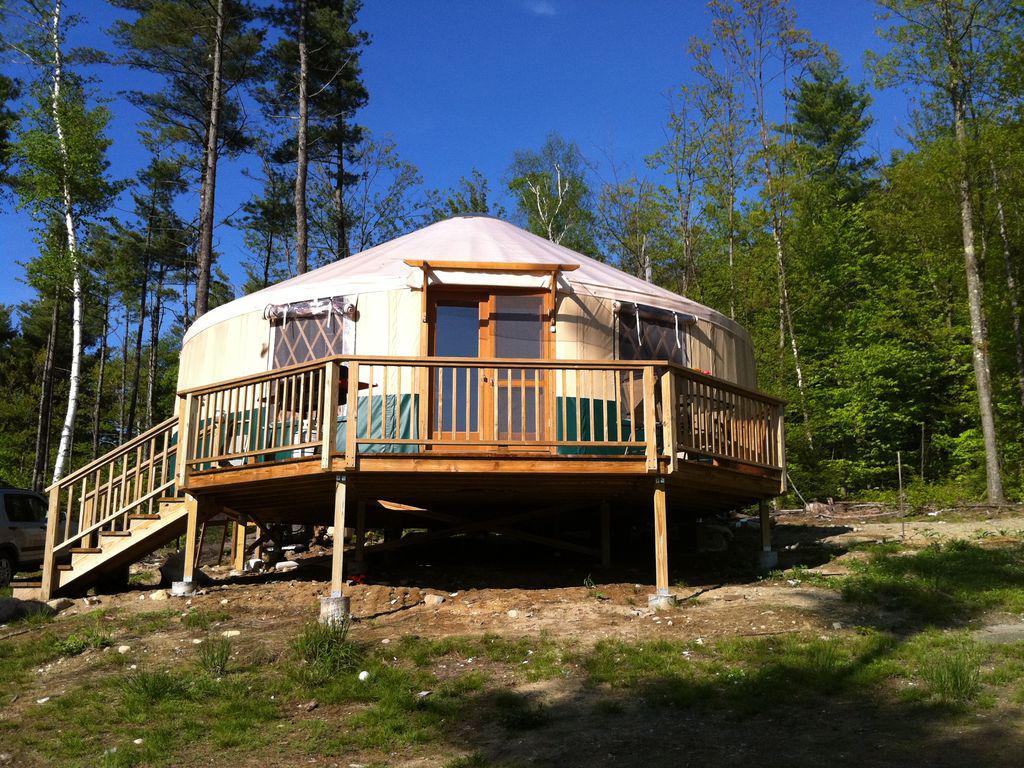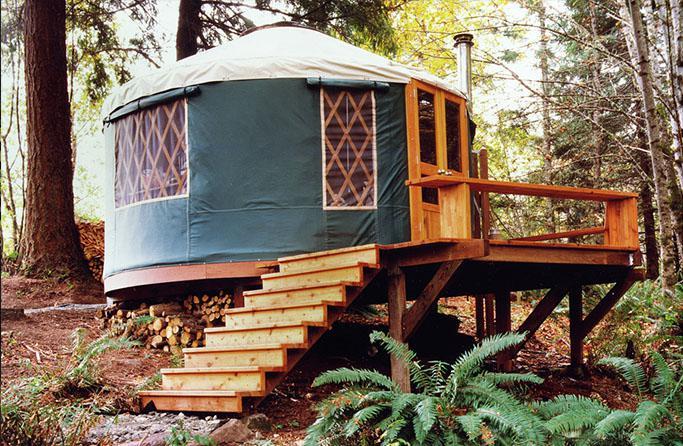The first image is the image on the left, the second image is the image on the right. Analyze the images presented: Is the assertion "An interior and an exterior image of a round house are shown." valid? Answer yes or no. No. 